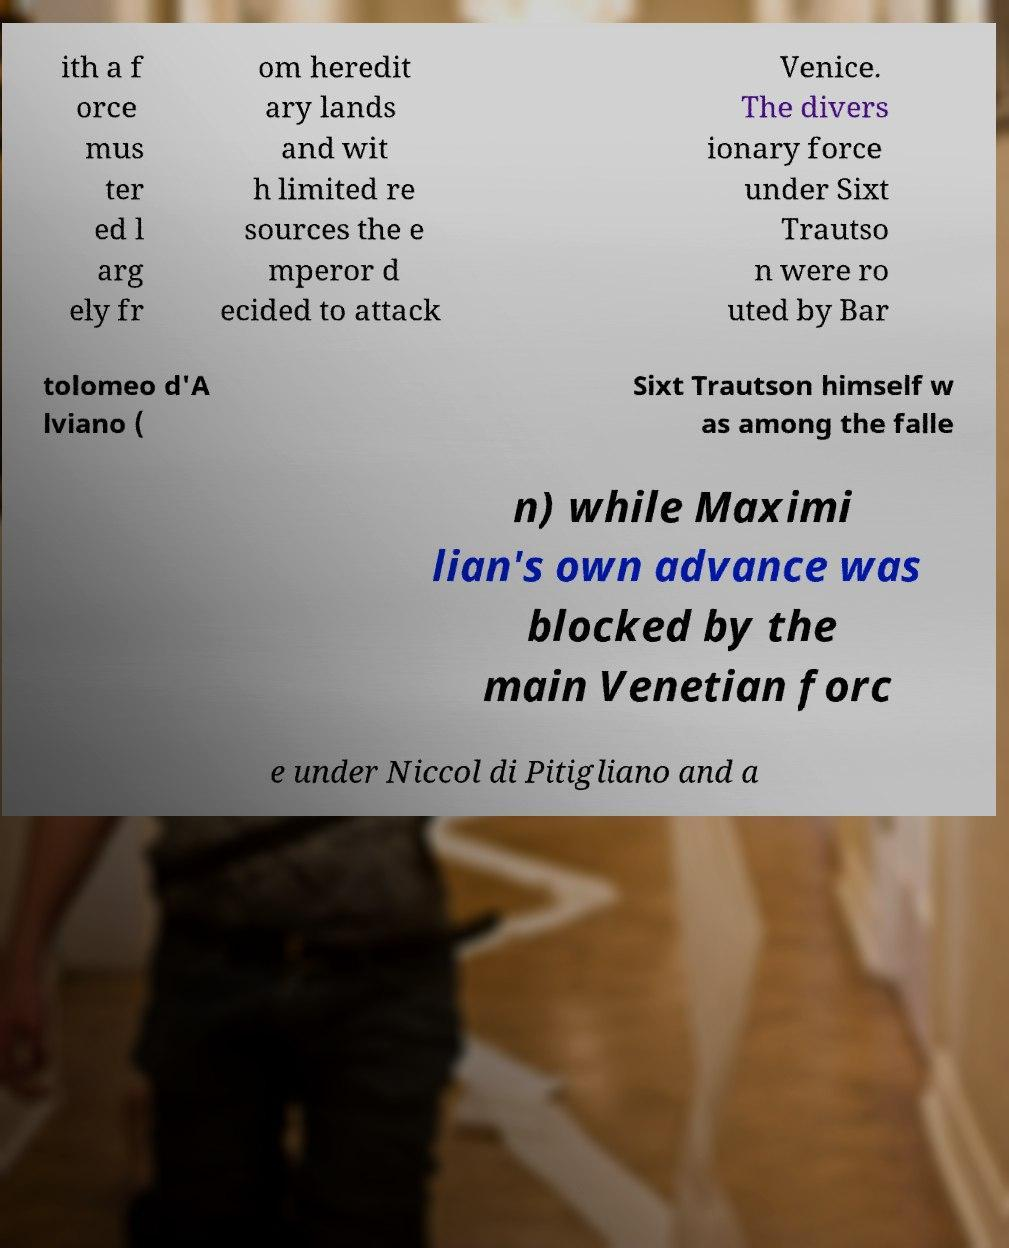Please read and relay the text visible in this image. What does it say? ith a f orce mus ter ed l arg ely fr om heredit ary lands and wit h limited re sources the e mperor d ecided to attack Venice. The divers ionary force under Sixt Trautso n were ro uted by Bar tolomeo d'A lviano ( Sixt Trautson himself w as among the falle n) while Maximi lian's own advance was blocked by the main Venetian forc e under Niccol di Pitigliano and a 